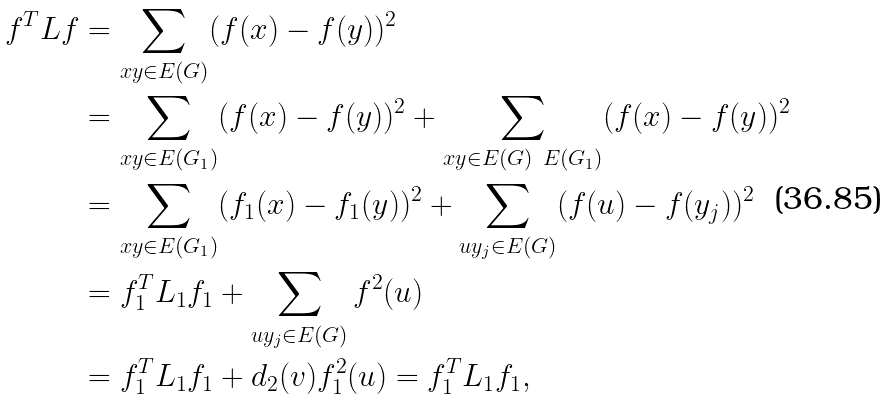<formula> <loc_0><loc_0><loc_500><loc_500>f ^ { T } L f & = \sum _ { x y \in E ( G ) } ( f ( x ) - f ( y ) ) ^ { 2 } \\ & = \sum _ { x y \in E ( G _ { 1 } ) } ( f ( x ) - f ( y ) ) ^ { 2 } + \sum _ { x y \in E ( G ) \ E ( G _ { 1 } ) } ( f ( x ) - f ( y ) ) ^ { 2 } \\ & = \sum _ { x y \in E ( G _ { 1 } ) } ( f _ { 1 } ( x ) - f _ { 1 } ( y ) ) ^ { 2 } + \sum _ { u y _ { j } \in E ( G ) } ( f ( u ) - f ( y _ { j } ) ) ^ { 2 } \\ & = f _ { 1 } ^ { T } L _ { 1 } f _ { 1 } + \sum _ { u y _ { j } \in E ( G ) } f ^ { 2 } ( u ) \\ & = f _ { 1 } ^ { T } L _ { 1 } f _ { 1 } + d _ { 2 } ( v ) f ^ { 2 } _ { 1 } ( u ) = f _ { 1 } ^ { T } L _ { 1 } f _ { 1 } ,</formula> 